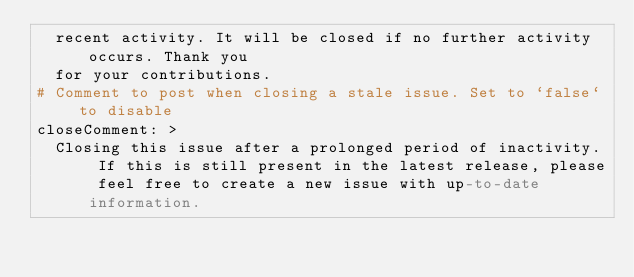<code> <loc_0><loc_0><loc_500><loc_500><_YAML_>  recent activity. It will be closed if no further activity occurs. Thank you
  for your contributions.
# Comment to post when closing a stale issue. Set to `false` to disable
closeComment: >
  Closing this issue after a prolonged period of inactivity. If this is still present in the latest release, please feel free to create a new issue with up-to-date information.
</code> 